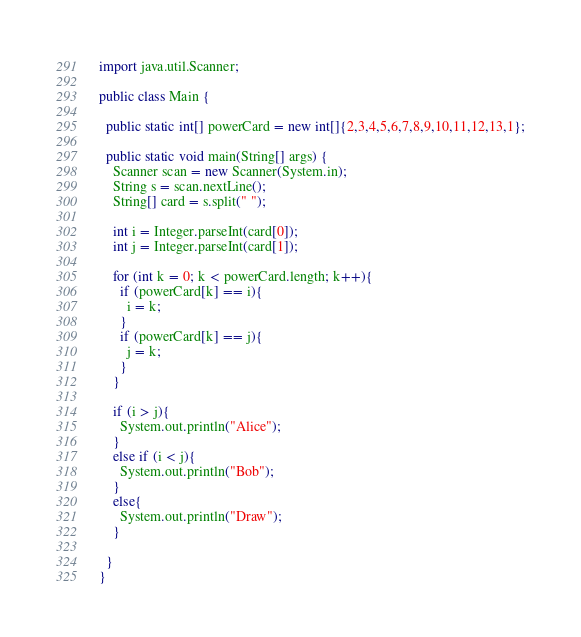Convert code to text. <code><loc_0><loc_0><loc_500><loc_500><_Java_>import java.util.Scanner;

public class Main {

  public static int[] powerCard = new int[]{2,3,4,5,6,7,8,9,10,11,12,13,1};

  public static void main(String[] args) {
    Scanner scan = new Scanner(System.in);
    String s = scan.nextLine();
    String[] card = s.split(" ");

    int i = Integer.parseInt(card[0]);
    int j = Integer.parseInt(card[1]);

    for (int k = 0; k < powerCard.length; k++){
      if (powerCard[k] == i){
        i = k;
      }
      if (powerCard[k] == j){
        j = k;
      }
    }

    if (i > j){
      System.out.println("Alice");
    }
    else if (i < j){
      System.out.println("Bob");
    }
    else{
      System.out.println("Draw");
    }

  }
}
</code> 